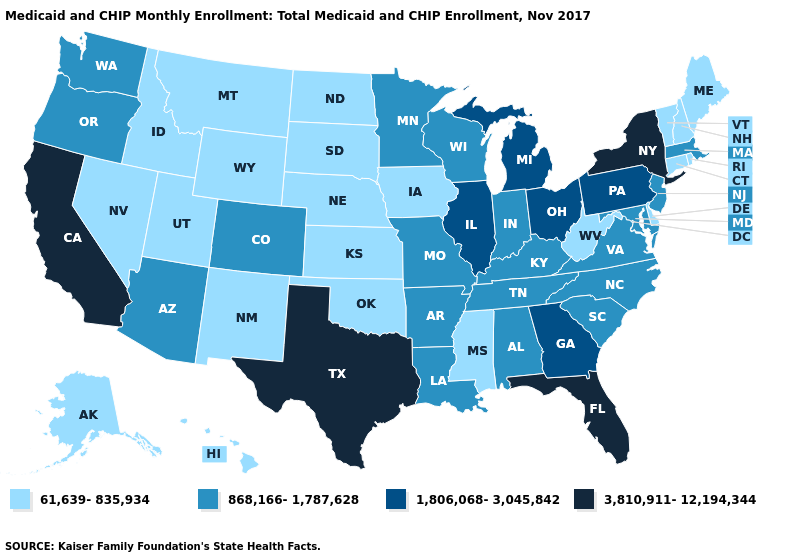Name the states that have a value in the range 3,810,911-12,194,344?
Keep it brief. California, Florida, New York, Texas. Does the map have missing data?
Concise answer only. No. Does New York have the highest value in the USA?
Answer briefly. Yes. Does the first symbol in the legend represent the smallest category?
Quick response, please. Yes. Name the states that have a value in the range 3,810,911-12,194,344?
Write a very short answer. California, Florida, New York, Texas. What is the highest value in the USA?
Write a very short answer. 3,810,911-12,194,344. Name the states that have a value in the range 61,639-835,934?
Short answer required. Alaska, Connecticut, Delaware, Hawaii, Idaho, Iowa, Kansas, Maine, Mississippi, Montana, Nebraska, Nevada, New Hampshire, New Mexico, North Dakota, Oklahoma, Rhode Island, South Dakota, Utah, Vermont, West Virginia, Wyoming. Name the states that have a value in the range 61,639-835,934?
Answer briefly. Alaska, Connecticut, Delaware, Hawaii, Idaho, Iowa, Kansas, Maine, Mississippi, Montana, Nebraska, Nevada, New Hampshire, New Mexico, North Dakota, Oklahoma, Rhode Island, South Dakota, Utah, Vermont, West Virginia, Wyoming. Name the states that have a value in the range 61,639-835,934?
Write a very short answer. Alaska, Connecticut, Delaware, Hawaii, Idaho, Iowa, Kansas, Maine, Mississippi, Montana, Nebraska, Nevada, New Hampshire, New Mexico, North Dakota, Oklahoma, Rhode Island, South Dakota, Utah, Vermont, West Virginia, Wyoming. Among the states that border Pennsylvania , which have the highest value?
Concise answer only. New York. What is the value of Kentucky?
Be succinct. 868,166-1,787,628. Name the states that have a value in the range 61,639-835,934?
Write a very short answer. Alaska, Connecticut, Delaware, Hawaii, Idaho, Iowa, Kansas, Maine, Mississippi, Montana, Nebraska, Nevada, New Hampshire, New Mexico, North Dakota, Oklahoma, Rhode Island, South Dakota, Utah, Vermont, West Virginia, Wyoming. What is the lowest value in the USA?
Short answer required. 61,639-835,934. Does Michigan have the lowest value in the USA?
Short answer required. No. Among the states that border West Virginia , does Maryland have the highest value?
Keep it brief. No. 